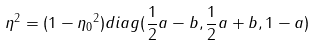<formula> <loc_0><loc_0><loc_500><loc_500>\eta ^ { 2 } = ( 1 - { \eta _ { 0 } } ^ { 2 } ) d i a g ( \frac { 1 } { 2 } a - b , \frac { 1 } { 2 } a + b , 1 - a )</formula> 